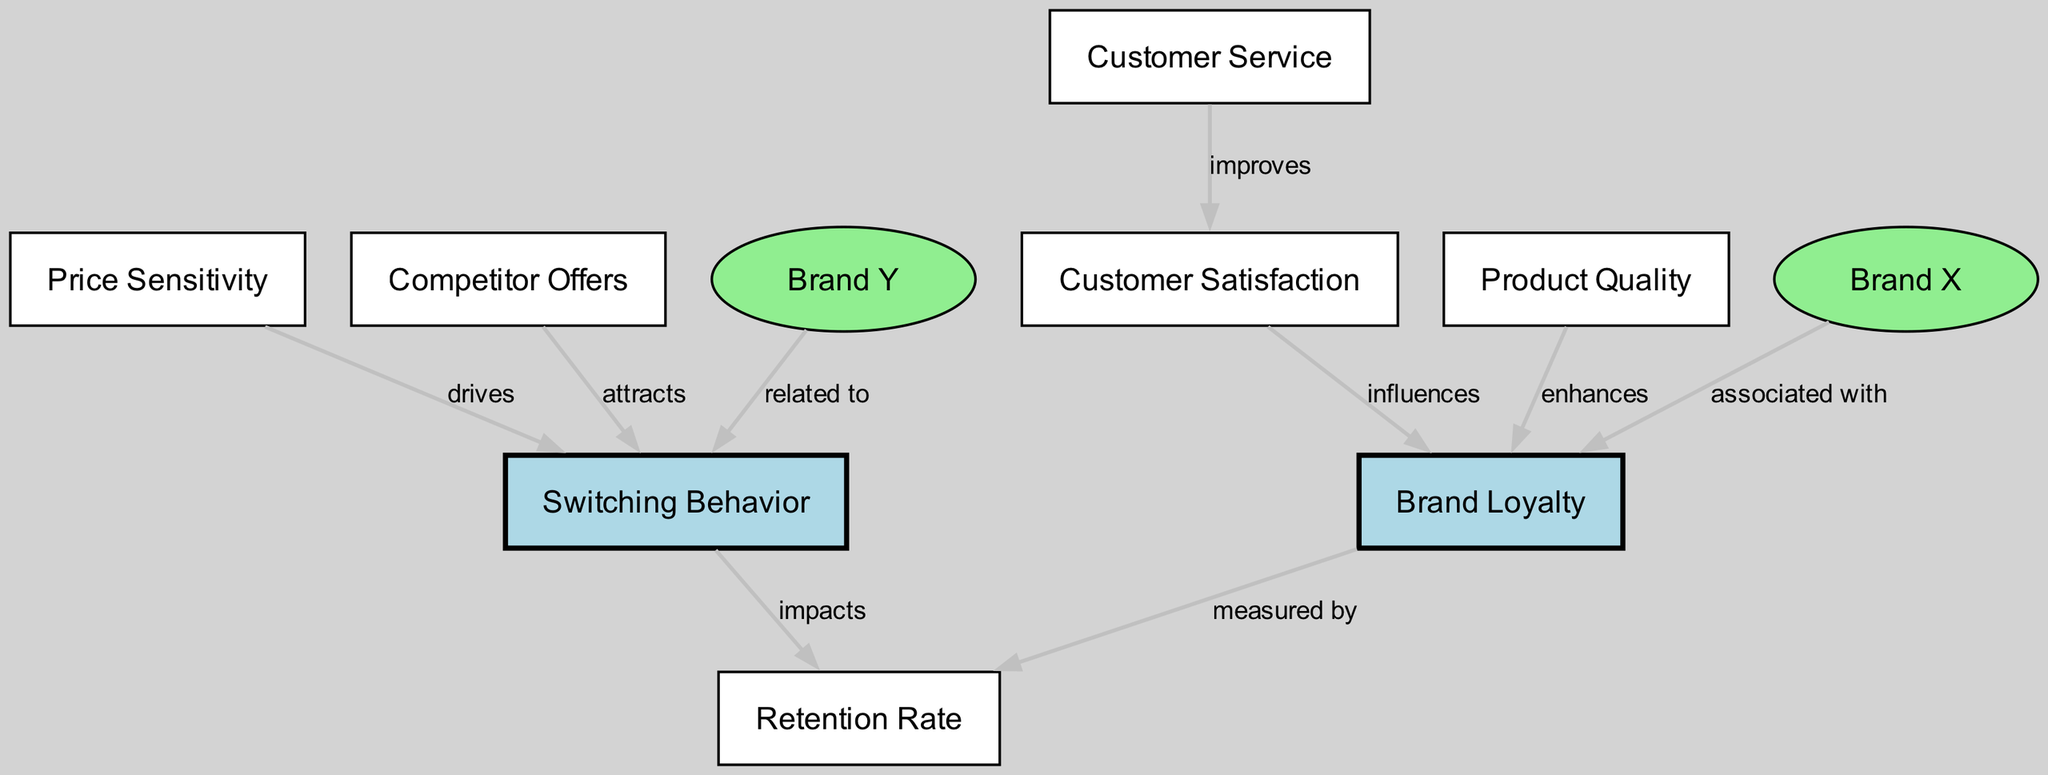What is the primary measure of brand loyalty in this diagram? The measure of brand loyalty is indicated as 'Retention Rate' in the diagram as it is directly linked to the 'Brand Loyalty' node.
Answer: Retention Rate Which factor improves customer satisfaction according to the diagram? The diagram shows that 'Customer Service' directly influences 'Customer Satisfaction', indicating that better customer service leads to higher satisfaction.
Answer: Customer Service How many edges are there in the diagram? By counting the lines connecting the nodes in the diagram, there are a total of 8 edges displayed.
Answer: 8 What does 'Price Sensitivity' drive according to the diagram? The 'Price Sensitivity' node has a direct edge to the 'Switching Behavior' node, which indicates it drives the frequency of consumers switching brands.
Answer: Switching Behavior Which brand is associated with brand loyalty? The diagram clearly states that 'Brand X' is associated with 'Brand Loyalty', suggesting that it has a strong connection to loyal consumers.
Answer: Brand X What influences brand loyalty as per this diagram? The diagram indicates that 'Customer Satisfaction' and 'Product Quality' directly influence 'Brand Loyalty', suggesting both factors are crucial for loyalty levels.
Answer: Customer Satisfaction and Product Quality Which node relates to switching behavior? The 'Brand Y' node is shown to be related to 'Switching Behavior', suggesting its characteristics may affect customers' decisions to switch brands.
Answer: Brand Y What attracts consumers to switch brands according to the diagram? The 'Competitor Offers' node is connected to 'Switching Behavior', indicating that attractive offers from competitors can lead consumers to switch brands.
Answer: Competitor Offers 